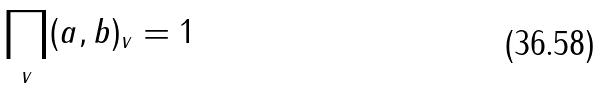Convert formula to latex. <formula><loc_0><loc_0><loc_500><loc_500>\prod _ { v } ( a , b ) _ { v } = 1</formula> 